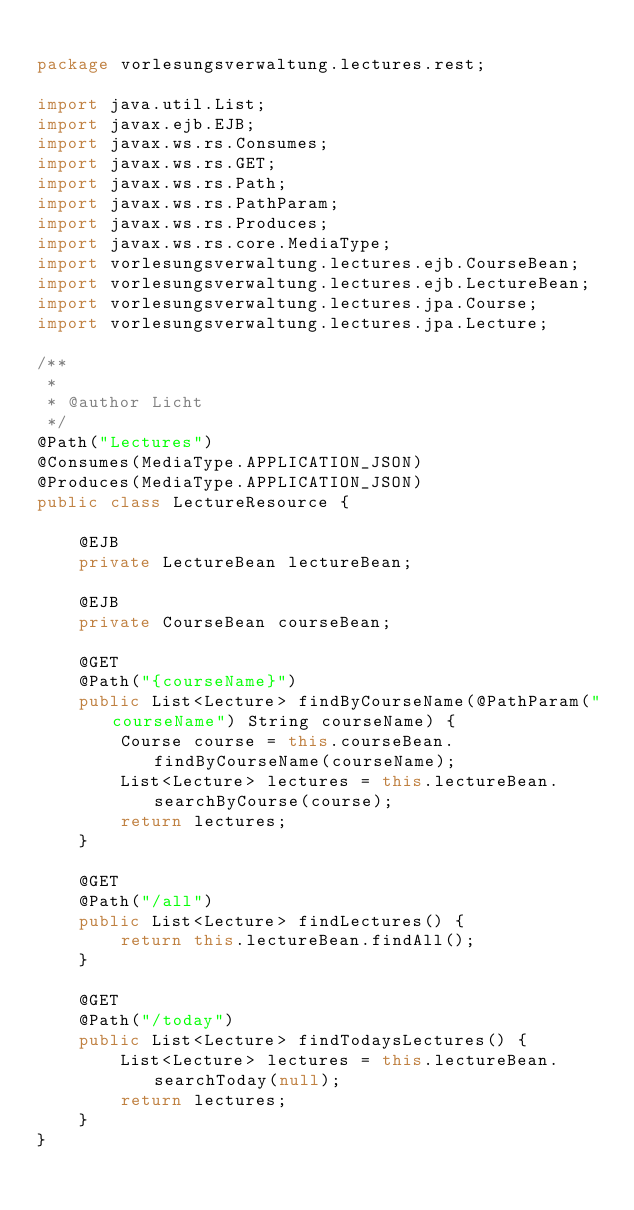Convert code to text. <code><loc_0><loc_0><loc_500><loc_500><_Java_>
package vorlesungsverwaltung.lectures.rest;

import java.util.List;
import javax.ejb.EJB;
import javax.ws.rs.Consumes;
import javax.ws.rs.GET;
import javax.ws.rs.Path;
import javax.ws.rs.PathParam;
import javax.ws.rs.Produces;
import javax.ws.rs.core.MediaType;
import vorlesungsverwaltung.lectures.ejb.CourseBean;
import vorlesungsverwaltung.lectures.ejb.LectureBean;
import vorlesungsverwaltung.lectures.jpa.Course;
import vorlesungsverwaltung.lectures.jpa.Lecture;

/**
 *
 * @author Licht
 */
@Path("Lectures")
@Consumes(MediaType.APPLICATION_JSON)
@Produces(MediaType.APPLICATION_JSON)
public class LectureResource {

    @EJB
    private LectureBean lectureBean;

    @EJB
    private CourseBean courseBean;

    @GET
    @Path("{courseName}")
    public List<Lecture> findByCourseName(@PathParam("courseName") String courseName) {
        Course course = this.courseBean.findByCourseName(courseName);
        List<Lecture> lectures = this.lectureBean.searchByCourse(course);
        return lectures;
    }

    @GET
    @Path("/all")
    public List<Lecture> findLectures() {
        return this.lectureBean.findAll();
    }

    @GET
    @Path("/today")
    public List<Lecture> findTodaysLectures() {
        List<Lecture> lectures = this.lectureBean.searchToday(null);
        return lectures;
    }
}
</code> 